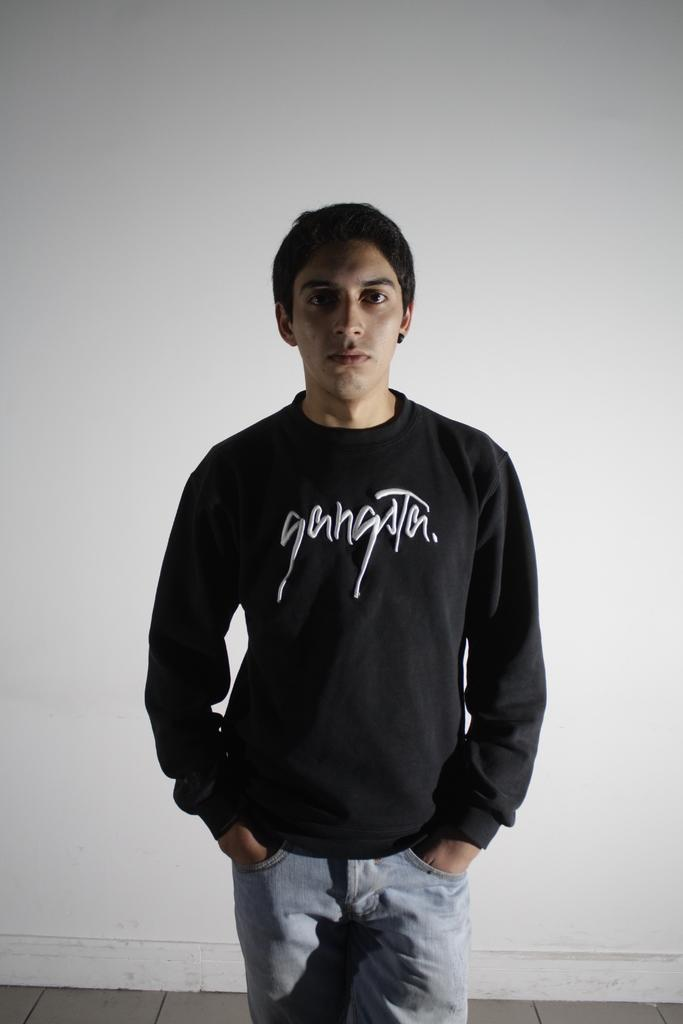Who is present in the image? There is a man in the image. What is the man wearing? The man is wearing a long black color T-shirt. What is written on the T-shirt? The T-shirt has the word "gangster" on it. What can be seen in the background of the image? There is a white wall in the background of the image. What type of brush is the man using to paint the volcano in the image? There is no brush or volcano present in the image; it only features a man wearing a T-shirt with the word "gangster" on it, standing in front of a white wall. 